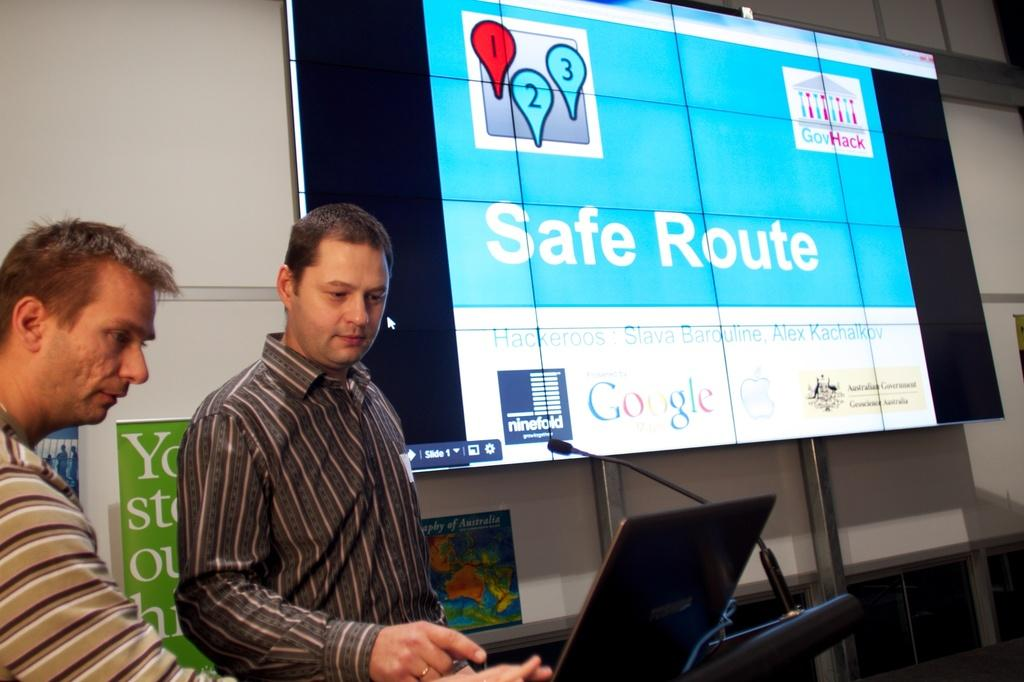What is in front of the wall in the image? There is a screen in front of the wall. Who or what can be seen in the image? People are visible in the image. What is behind the people in the image? There is a map and hoardings behind the people. What is on the podium in the image? A microphone and a laptop are on the podium. What type of marble is visible on the podium in the image? There is no marble visible on the podium in the image. How much debt is being discussed in the image? There is no discussion of debt in the image. 